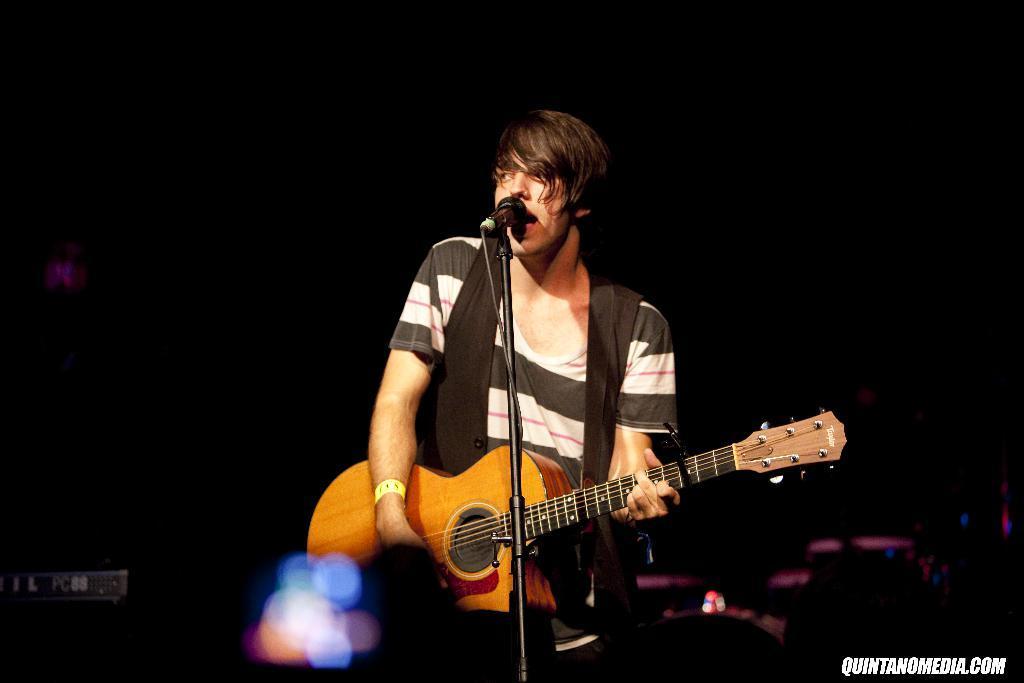Please provide a concise description of this image. In the middle of the image a man is standing and playing guitar and singing on the microphone. 